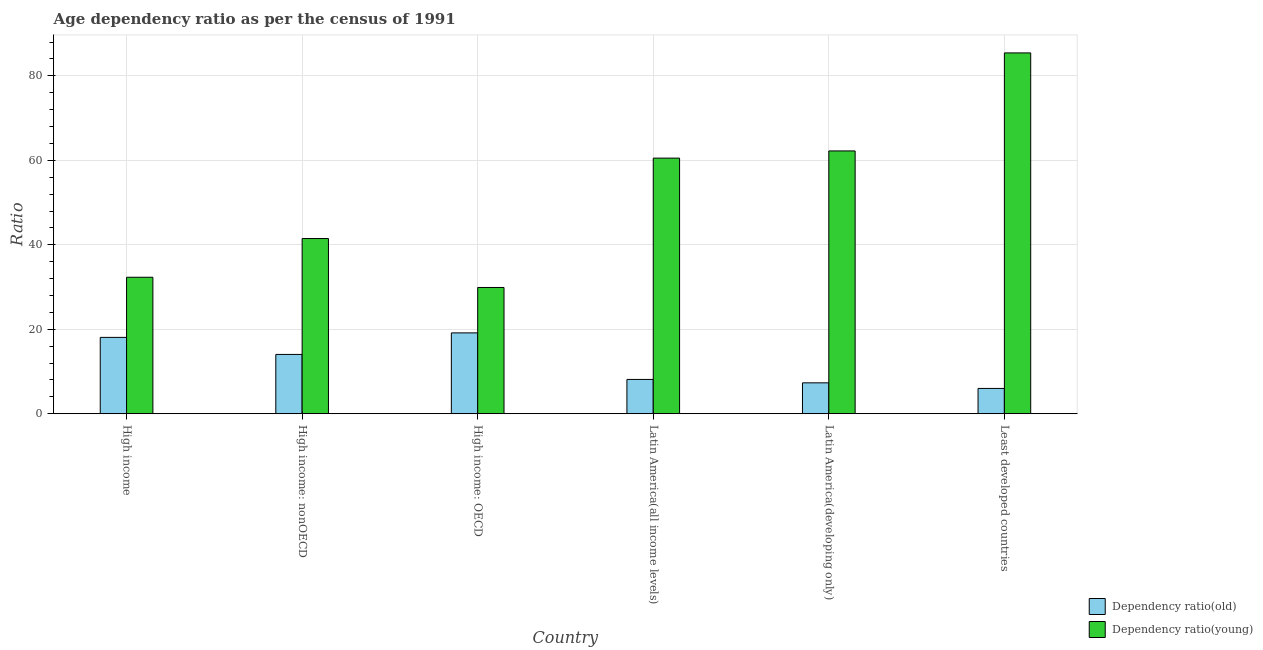How many different coloured bars are there?
Provide a succinct answer. 2. Are the number of bars per tick equal to the number of legend labels?
Your response must be concise. Yes. Are the number of bars on each tick of the X-axis equal?
Ensure brevity in your answer.  Yes. How many bars are there on the 2nd tick from the left?
Your response must be concise. 2. In how many cases, is the number of bars for a given country not equal to the number of legend labels?
Your response must be concise. 0. What is the age dependency ratio(old) in High income: nonOECD?
Offer a terse response. 14.04. Across all countries, what is the maximum age dependency ratio(young)?
Provide a short and direct response. 85.44. Across all countries, what is the minimum age dependency ratio(old)?
Give a very brief answer. 5.99. In which country was the age dependency ratio(young) maximum?
Your answer should be compact. Least developed countries. In which country was the age dependency ratio(old) minimum?
Make the answer very short. Least developed countries. What is the total age dependency ratio(old) in the graph?
Your answer should be compact. 72.7. What is the difference between the age dependency ratio(old) in High income: OECD and that in Latin America(developing only)?
Your answer should be very brief. 11.83. What is the difference between the age dependency ratio(old) in High income: nonOECD and the age dependency ratio(young) in High income?
Offer a very short reply. -18.27. What is the average age dependency ratio(old) per country?
Offer a terse response. 12.12. What is the difference between the age dependency ratio(young) and age dependency ratio(old) in High income?
Make the answer very short. 14.24. In how many countries, is the age dependency ratio(old) greater than 20 ?
Your answer should be very brief. 0. What is the ratio of the age dependency ratio(old) in High income: OECD to that in High income: nonOECD?
Provide a short and direct response. 1.36. Is the age dependency ratio(old) in High income: nonOECD less than that in Latin America(all income levels)?
Ensure brevity in your answer.  No. Is the difference between the age dependency ratio(old) in High income and Least developed countries greater than the difference between the age dependency ratio(young) in High income and Least developed countries?
Make the answer very short. Yes. What is the difference between the highest and the second highest age dependency ratio(young)?
Your answer should be very brief. 23.21. What is the difference between the highest and the lowest age dependency ratio(old)?
Offer a terse response. 13.15. In how many countries, is the age dependency ratio(old) greater than the average age dependency ratio(old) taken over all countries?
Your answer should be very brief. 3. Is the sum of the age dependency ratio(young) in High income and High income: nonOECD greater than the maximum age dependency ratio(old) across all countries?
Offer a very short reply. Yes. What does the 2nd bar from the left in High income: OECD represents?
Make the answer very short. Dependency ratio(young). What does the 2nd bar from the right in High income represents?
Keep it short and to the point. Dependency ratio(old). Are all the bars in the graph horizontal?
Give a very brief answer. No. How are the legend labels stacked?
Your response must be concise. Vertical. What is the title of the graph?
Offer a very short reply. Age dependency ratio as per the census of 1991. What is the label or title of the Y-axis?
Provide a succinct answer. Ratio. What is the Ratio of Dependency ratio(old) in High income?
Keep it short and to the point. 18.08. What is the Ratio of Dependency ratio(young) in High income?
Keep it short and to the point. 32.32. What is the Ratio of Dependency ratio(old) in High income: nonOECD?
Your answer should be very brief. 14.04. What is the Ratio in Dependency ratio(young) in High income: nonOECD?
Give a very brief answer. 41.49. What is the Ratio of Dependency ratio(old) in High income: OECD?
Provide a succinct answer. 19.15. What is the Ratio in Dependency ratio(young) in High income: OECD?
Your answer should be very brief. 29.9. What is the Ratio of Dependency ratio(old) in Latin America(all income levels)?
Make the answer very short. 8.12. What is the Ratio of Dependency ratio(young) in Latin America(all income levels)?
Offer a very short reply. 60.53. What is the Ratio in Dependency ratio(old) in Latin America(developing only)?
Keep it short and to the point. 7.32. What is the Ratio of Dependency ratio(young) in Latin America(developing only)?
Provide a succinct answer. 62.23. What is the Ratio of Dependency ratio(old) in Least developed countries?
Give a very brief answer. 5.99. What is the Ratio in Dependency ratio(young) in Least developed countries?
Offer a very short reply. 85.44. Across all countries, what is the maximum Ratio in Dependency ratio(old)?
Your response must be concise. 19.15. Across all countries, what is the maximum Ratio of Dependency ratio(young)?
Keep it short and to the point. 85.44. Across all countries, what is the minimum Ratio of Dependency ratio(old)?
Your response must be concise. 5.99. Across all countries, what is the minimum Ratio in Dependency ratio(young)?
Keep it short and to the point. 29.9. What is the total Ratio in Dependency ratio(old) in the graph?
Make the answer very short. 72.7. What is the total Ratio of Dependency ratio(young) in the graph?
Your answer should be very brief. 311.9. What is the difference between the Ratio in Dependency ratio(old) in High income and that in High income: nonOECD?
Keep it short and to the point. 4.04. What is the difference between the Ratio of Dependency ratio(young) in High income and that in High income: nonOECD?
Your answer should be compact. -9.17. What is the difference between the Ratio of Dependency ratio(old) in High income and that in High income: OECD?
Make the answer very short. -1.07. What is the difference between the Ratio of Dependency ratio(young) in High income and that in High income: OECD?
Ensure brevity in your answer.  2.42. What is the difference between the Ratio of Dependency ratio(old) in High income and that in Latin America(all income levels)?
Your answer should be compact. 9.96. What is the difference between the Ratio of Dependency ratio(young) in High income and that in Latin America(all income levels)?
Offer a terse response. -28.21. What is the difference between the Ratio of Dependency ratio(old) in High income and that in Latin America(developing only)?
Provide a short and direct response. 10.76. What is the difference between the Ratio in Dependency ratio(young) in High income and that in Latin America(developing only)?
Your answer should be very brief. -29.91. What is the difference between the Ratio in Dependency ratio(old) in High income and that in Least developed countries?
Offer a very short reply. 12.09. What is the difference between the Ratio in Dependency ratio(young) in High income and that in Least developed countries?
Your answer should be very brief. -53.12. What is the difference between the Ratio in Dependency ratio(old) in High income: nonOECD and that in High income: OECD?
Offer a very short reply. -5.1. What is the difference between the Ratio of Dependency ratio(young) in High income: nonOECD and that in High income: OECD?
Keep it short and to the point. 11.59. What is the difference between the Ratio of Dependency ratio(old) in High income: nonOECD and that in Latin America(all income levels)?
Your response must be concise. 5.92. What is the difference between the Ratio in Dependency ratio(young) in High income: nonOECD and that in Latin America(all income levels)?
Your answer should be compact. -19.04. What is the difference between the Ratio of Dependency ratio(old) in High income: nonOECD and that in Latin America(developing only)?
Give a very brief answer. 6.73. What is the difference between the Ratio in Dependency ratio(young) in High income: nonOECD and that in Latin America(developing only)?
Provide a short and direct response. -20.74. What is the difference between the Ratio of Dependency ratio(old) in High income: nonOECD and that in Least developed countries?
Give a very brief answer. 8.05. What is the difference between the Ratio in Dependency ratio(young) in High income: nonOECD and that in Least developed countries?
Keep it short and to the point. -43.95. What is the difference between the Ratio in Dependency ratio(old) in High income: OECD and that in Latin America(all income levels)?
Your response must be concise. 11.02. What is the difference between the Ratio in Dependency ratio(young) in High income: OECD and that in Latin America(all income levels)?
Ensure brevity in your answer.  -30.63. What is the difference between the Ratio of Dependency ratio(old) in High income: OECD and that in Latin America(developing only)?
Your answer should be compact. 11.83. What is the difference between the Ratio in Dependency ratio(young) in High income: OECD and that in Latin America(developing only)?
Offer a terse response. -32.33. What is the difference between the Ratio in Dependency ratio(old) in High income: OECD and that in Least developed countries?
Offer a very short reply. 13.15. What is the difference between the Ratio in Dependency ratio(young) in High income: OECD and that in Least developed countries?
Offer a terse response. -55.54. What is the difference between the Ratio in Dependency ratio(old) in Latin America(all income levels) and that in Latin America(developing only)?
Offer a terse response. 0.8. What is the difference between the Ratio in Dependency ratio(young) in Latin America(all income levels) and that in Latin America(developing only)?
Provide a succinct answer. -1.7. What is the difference between the Ratio in Dependency ratio(old) in Latin America(all income levels) and that in Least developed countries?
Your response must be concise. 2.13. What is the difference between the Ratio in Dependency ratio(young) in Latin America(all income levels) and that in Least developed countries?
Ensure brevity in your answer.  -24.91. What is the difference between the Ratio in Dependency ratio(old) in Latin America(developing only) and that in Least developed countries?
Keep it short and to the point. 1.33. What is the difference between the Ratio of Dependency ratio(young) in Latin America(developing only) and that in Least developed countries?
Offer a very short reply. -23.21. What is the difference between the Ratio of Dependency ratio(old) in High income and the Ratio of Dependency ratio(young) in High income: nonOECD?
Your response must be concise. -23.41. What is the difference between the Ratio of Dependency ratio(old) in High income and the Ratio of Dependency ratio(young) in High income: OECD?
Your answer should be very brief. -11.82. What is the difference between the Ratio in Dependency ratio(old) in High income and the Ratio in Dependency ratio(young) in Latin America(all income levels)?
Your answer should be compact. -42.45. What is the difference between the Ratio in Dependency ratio(old) in High income and the Ratio in Dependency ratio(young) in Latin America(developing only)?
Your response must be concise. -44.15. What is the difference between the Ratio in Dependency ratio(old) in High income and the Ratio in Dependency ratio(young) in Least developed countries?
Offer a terse response. -67.36. What is the difference between the Ratio of Dependency ratio(old) in High income: nonOECD and the Ratio of Dependency ratio(young) in High income: OECD?
Ensure brevity in your answer.  -15.85. What is the difference between the Ratio in Dependency ratio(old) in High income: nonOECD and the Ratio in Dependency ratio(young) in Latin America(all income levels)?
Your answer should be compact. -46.48. What is the difference between the Ratio of Dependency ratio(old) in High income: nonOECD and the Ratio of Dependency ratio(young) in Latin America(developing only)?
Provide a succinct answer. -48.19. What is the difference between the Ratio of Dependency ratio(old) in High income: nonOECD and the Ratio of Dependency ratio(young) in Least developed countries?
Your answer should be compact. -71.39. What is the difference between the Ratio in Dependency ratio(old) in High income: OECD and the Ratio in Dependency ratio(young) in Latin America(all income levels)?
Keep it short and to the point. -41.38. What is the difference between the Ratio in Dependency ratio(old) in High income: OECD and the Ratio in Dependency ratio(young) in Latin America(developing only)?
Give a very brief answer. -43.08. What is the difference between the Ratio of Dependency ratio(old) in High income: OECD and the Ratio of Dependency ratio(young) in Least developed countries?
Keep it short and to the point. -66.29. What is the difference between the Ratio of Dependency ratio(old) in Latin America(all income levels) and the Ratio of Dependency ratio(young) in Latin America(developing only)?
Your answer should be compact. -54.11. What is the difference between the Ratio of Dependency ratio(old) in Latin America(all income levels) and the Ratio of Dependency ratio(young) in Least developed countries?
Your response must be concise. -77.32. What is the difference between the Ratio in Dependency ratio(old) in Latin America(developing only) and the Ratio in Dependency ratio(young) in Least developed countries?
Your answer should be compact. -78.12. What is the average Ratio in Dependency ratio(old) per country?
Your answer should be compact. 12.12. What is the average Ratio of Dependency ratio(young) per country?
Offer a very short reply. 51.98. What is the difference between the Ratio of Dependency ratio(old) and Ratio of Dependency ratio(young) in High income?
Your answer should be compact. -14.24. What is the difference between the Ratio of Dependency ratio(old) and Ratio of Dependency ratio(young) in High income: nonOECD?
Provide a short and direct response. -27.44. What is the difference between the Ratio in Dependency ratio(old) and Ratio in Dependency ratio(young) in High income: OECD?
Ensure brevity in your answer.  -10.75. What is the difference between the Ratio of Dependency ratio(old) and Ratio of Dependency ratio(young) in Latin America(all income levels)?
Your answer should be compact. -52.41. What is the difference between the Ratio of Dependency ratio(old) and Ratio of Dependency ratio(young) in Latin America(developing only)?
Ensure brevity in your answer.  -54.91. What is the difference between the Ratio of Dependency ratio(old) and Ratio of Dependency ratio(young) in Least developed countries?
Provide a succinct answer. -79.45. What is the ratio of the Ratio of Dependency ratio(old) in High income to that in High income: nonOECD?
Provide a short and direct response. 1.29. What is the ratio of the Ratio of Dependency ratio(young) in High income to that in High income: nonOECD?
Offer a very short reply. 0.78. What is the ratio of the Ratio in Dependency ratio(old) in High income to that in High income: OECD?
Give a very brief answer. 0.94. What is the ratio of the Ratio in Dependency ratio(young) in High income to that in High income: OECD?
Provide a succinct answer. 1.08. What is the ratio of the Ratio in Dependency ratio(old) in High income to that in Latin America(all income levels)?
Make the answer very short. 2.23. What is the ratio of the Ratio of Dependency ratio(young) in High income to that in Latin America(all income levels)?
Ensure brevity in your answer.  0.53. What is the ratio of the Ratio in Dependency ratio(old) in High income to that in Latin America(developing only)?
Keep it short and to the point. 2.47. What is the ratio of the Ratio in Dependency ratio(young) in High income to that in Latin America(developing only)?
Provide a succinct answer. 0.52. What is the ratio of the Ratio in Dependency ratio(old) in High income to that in Least developed countries?
Your answer should be compact. 3.02. What is the ratio of the Ratio in Dependency ratio(young) in High income to that in Least developed countries?
Make the answer very short. 0.38. What is the ratio of the Ratio of Dependency ratio(old) in High income: nonOECD to that in High income: OECD?
Give a very brief answer. 0.73. What is the ratio of the Ratio in Dependency ratio(young) in High income: nonOECD to that in High income: OECD?
Give a very brief answer. 1.39. What is the ratio of the Ratio of Dependency ratio(old) in High income: nonOECD to that in Latin America(all income levels)?
Offer a very short reply. 1.73. What is the ratio of the Ratio in Dependency ratio(young) in High income: nonOECD to that in Latin America(all income levels)?
Ensure brevity in your answer.  0.69. What is the ratio of the Ratio in Dependency ratio(old) in High income: nonOECD to that in Latin America(developing only)?
Your answer should be very brief. 1.92. What is the ratio of the Ratio of Dependency ratio(old) in High income: nonOECD to that in Least developed countries?
Offer a very short reply. 2.34. What is the ratio of the Ratio of Dependency ratio(young) in High income: nonOECD to that in Least developed countries?
Your response must be concise. 0.49. What is the ratio of the Ratio in Dependency ratio(old) in High income: OECD to that in Latin America(all income levels)?
Offer a terse response. 2.36. What is the ratio of the Ratio in Dependency ratio(young) in High income: OECD to that in Latin America(all income levels)?
Your response must be concise. 0.49. What is the ratio of the Ratio in Dependency ratio(old) in High income: OECD to that in Latin America(developing only)?
Give a very brief answer. 2.62. What is the ratio of the Ratio of Dependency ratio(young) in High income: OECD to that in Latin America(developing only)?
Ensure brevity in your answer.  0.48. What is the ratio of the Ratio of Dependency ratio(old) in High income: OECD to that in Least developed countries?
Give a very brief answer. 3.2. What is the ratio of the Ratio of Dependency ratio(young) in High income: OECD to that in Least developed countries?
Make the answer very short. 0.35. What is the ratio of the Ratio in Dependency ratio(old) in Latin America(all income levels) to that in Latin America(developing only)?
Your answer should be compact. 1.11. What is the ratio of the Ratio in Dependency ratio(young) in Latin America(all income levels) to that in Latin America(developing only)?
Your answer should be very brief. 0.97. What is the ratio of the Ratio of Dependency ratio(old) in Latin America(all income levels) to that in Least developed countries?
Provide a short and direct response. 1.36. What is the ratio of the Ratio of Dependency ratio(young) in Latin America(all income levels) to that in Least developed countries?
Provide a short and direct response. 0.71. What is the ratio of the Ratio of Dependency ratio(old) in Latin America(developing only) to that in Least developed countries?
Keep it short and to the point. 1.22. What is the ratio of the Ratio of Dependency ratio(young) in Latin America(developing only) to that in Least developed countries?
Offer a terse response. 0.73. What is the difference between the highest and the second highest Ratio of Dependency ratio(old)?
Your answer should be compact. 1.07. What is the difference between the highest and the second highest Ratio in Dependency ratio(young)?
Your response must be concise. 23.21. What is the difference between the highest and the lowest Ratio of Dependency ratio(old)?
Give a very brief answer. 13.15. What is the difference between the highest and the lowest Ratio of Dependency ratio(young)?
Your answer should be compact. 55.54. 